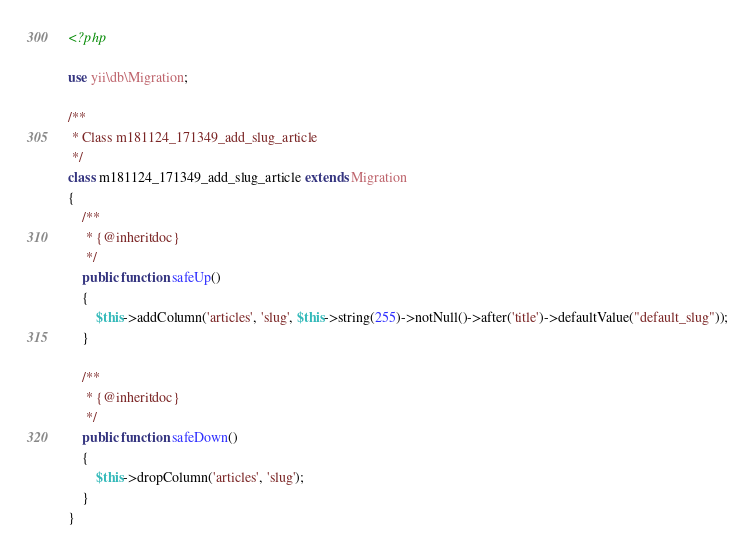<code> <loc_0><loc_0><loc_500><loc_500><_PHP_><?php

use yii\db\Migration;

/**
 * Class m181124_171349_add_slug_article
 */
class m181124_171349_add_slug_article extends Migration
{
    /**
     * {@inheritdoc}
     */
    public function safeUp()
    {
        $this->addColumn('articles', 'slug', $this->string(255)->notNull()->after('title')->defaultValue("default_slug"));
    }

    /**
     * {@inheritdoc}
     */
    public function safeDown()
    {
        $this->dropColumn('articles', 'slug');
    }
}
</code> 